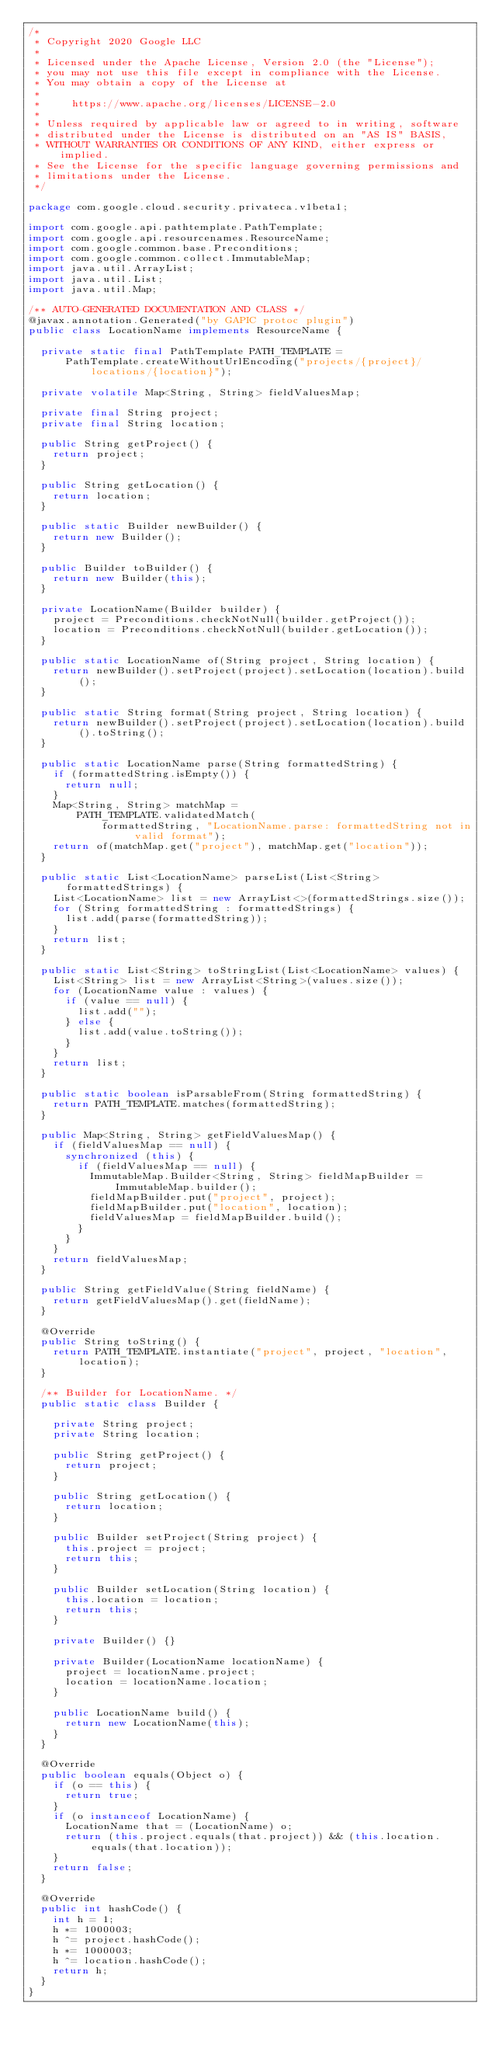Convert code to text. <code><loc_0><loc_0><loc_500><loc_500><_Java_>/*
 * Copyright 2020 Google LLC
 *
 * Licensed under the Apache License, Version 2.0 (the "License");
 * you may not use this file except in compliance with the License.
 * You may obtain a copy of the License at
 *
 *     https://www.apache.org/licenses/LICENSE-2.0
 *
 * Unless required by applicable law or agreed to in writing, software
 * distributed under the License is distributed on an "AS IS" BASIS,
 * WITHOUT WARRANTIES OR CONDITIONS OF ANY KIND, either express or implied.
 * See the License for the specific language governing permissions and
 * limitations under the License.
 */

package com.google.cloud.security.privateca.v1beta1;

import com.google.api.pathtemplate.PathTemplate;
import com.google.api.resourcenames.ResourceName;
import com.google.common.base.Preconditions;
import com.google.common.collect.ImmutableMap;
import java.util.ArrayList;
import java.util.List;
import java.util.Map;

/** AUTO-GENERATED DOCUMENTATION AND CLASS */
@javax.annotation.Generated("by GAPIC protoc plugin")
public class LocationName implements ResourceName {

  private static final PathTemplate PATH_TEMPLATE =
      PathTemplate.createWithoutUrlEncoding("projects/{project}/locations/{location}");

  private volatile Map<String, String> fieldValuesMap;

  private final String project;
  private final String location;

  public String getProject() {
    return project;
  }

  public String getLocation() {
    return location;
  }

  public static Builder newBuilder() {
    return new Builder();
  }

  public Builder toBuilder() {
    return new Builder(this);
  }

  private LocationName(Builder builder) {
    project = Preconditions.checkNotNull(builder.getProject());
    location = Preconditions.checkNotNull(builder.getLocation());
  }

  public static LocationName of(String project, String location) {
    return newBuilder().setProject(project).setLocation(location).build();
  }

  public static String format(String project, String location) {
    return newBuilder().setProject(project).setLocation(location).build().toString();
  }

  public static LocationName parse(String formattedString) {
    if (formattedString.isEmpty()) {
      return null;
    }
    Map<String, String> matchMap =
        PATH_TEMPLATE.validatedMatch(
            formattedString, "LocationName.parse: formattedString not in valid format");
    return of(matchMap.get("project"), matchMap.get("location"));
  }

  public static List<LocationName> parseList(List<String> formattedStrings) {
    List<LocationName> list = new ArrayList<>(formattedStrings.size());
    for (String formattedString : formattedStrings) {
      list.add(parse(formattedString));
    }
    return list;
  }

  public static List<String> toStringList(List<LocationName> values) {
    List<String> list = new ArrayList<String>(values.size());
    for (LocationName value : values) {
      if (value == null) {
        list.add("");
      } else {
        list.add(value.toString());
      }
    }
    return list;
  }

  public static boolean isParsableFrom(String formattedString) {
    return PATH_TEMPLATE.matches(formattedString);
  }

  public Map<String, String> getFieldValuesMap() {
    if (fieldValuesMap == null) {
      synchronized (this) {
        if (fieldValuesMap == null) {
          ImmutableMap.Builder<String, String> fieldMapBuilder = ImmutableMap.builder();
          fieldMapBuilder.put("project", project);
          fieldMapBuilder.put("location", location);
          fieldValuesMap = fieldMapBuilder.build();
        }
      }
    }
    return fieldValuesMap;
  }

  public String getFieldValue(String fieldName) {
    return getFieldValuesMap().get(fieldName);
  }

  @Override
  public String toString() {
    return PATH_TEMPLATE.instantiate("project", project, "location", location);
  }

  /** Builder for LocationName. */
  public static class Builder {

    private String project;
    private String location;

    public String getProject() {
      return project;
    }

    public String getLocation() {
      return location;
    }

    public Builder setProject(String project) {
      this.project = project;
      return this;
    }

    public Builder setLocation(String location) {
      this.location = location;
      return this;
    }

    private Builder() {}

    private Builder(LocationName locationName) {
      project = locationName.project;
      location = locationName.location;
    }

    public LocationName build() {
      return new LocationName(this);
    }
  }

  @Override
  public boolean equals(Object o) {
    if (o == this) {
      return true;
    }
    if (o instanceof LocationName) {
      LocationName that = (LocationName) o;
      return (this.project.equals(that.project)) && (this.location.equals(that.location));
    }
    return false;
  }

  @Override
  public int hashCode() {
    int h = 1;
    h *= 1000003;
    h ^= project.hashCode();
    h *= 1000003;
    h ^= location.hashCode();
    return h;
  }
}
</code> 